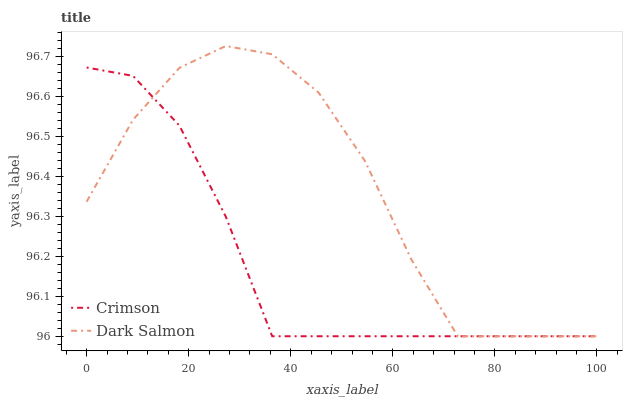Does Crimson have the minimum area under the curve?
Answer yes or no. Yes. Does Dark Salmon have the maximum area under the curve?
Answer yes or no. Yes. Does Dark Salmon have the minimum area under the curve?
Answer yes or no. No. Is Crimson the smoothest?
Answer yes or no. Yes. Is Dark Salmon the roughest?
Answer yes or no. Yes. Is Dark Salmon the smoothest?
Answer yes or no. No. Does Crimson have the lowest value?
Answer yes or no. Yes. Does Dark Salmon have the highest value?
Answer yes or no. Yes. Does Dark Salmon intersect Crimson?
Answer yes or no. Yes. Is Dark Salmon less than Crimson?
Answer yes or no. No. Is Dark Salmon greater than Crimson?
Answer yes or no. No. 